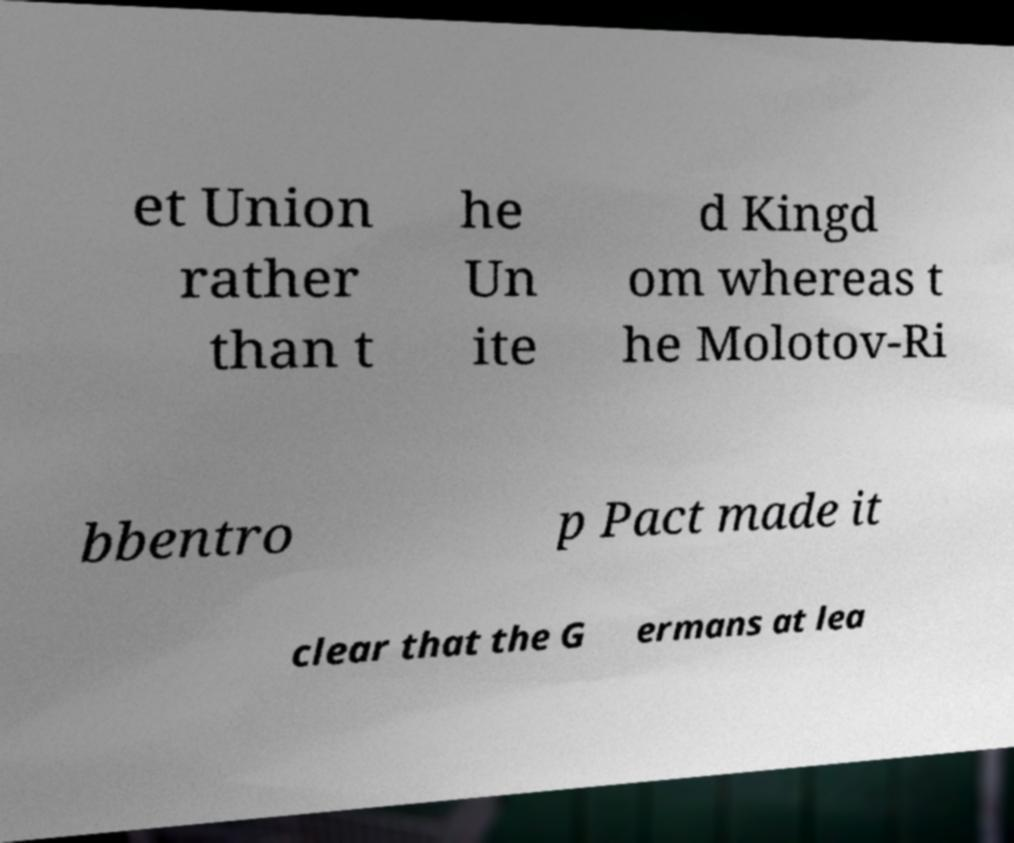Can you read and provide the text displayed in the image?This photo seems to have some interesting text. Can you extract and type it out for me? et Union rather than t he Un ite d Kingd om whereas t he Molotov-Ri bbentro p Pact made it clear that the G ermans at lea 